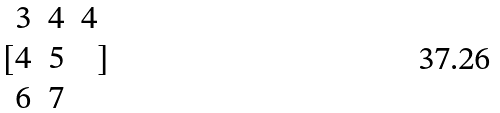<formula> <loc_0><loc_0><loc_500><loc_500>[ \begin{matrix} 3 & 4 & 4 \\ 4 & 5 \\ 6 & 7 \end{matrix} ]</formula> 